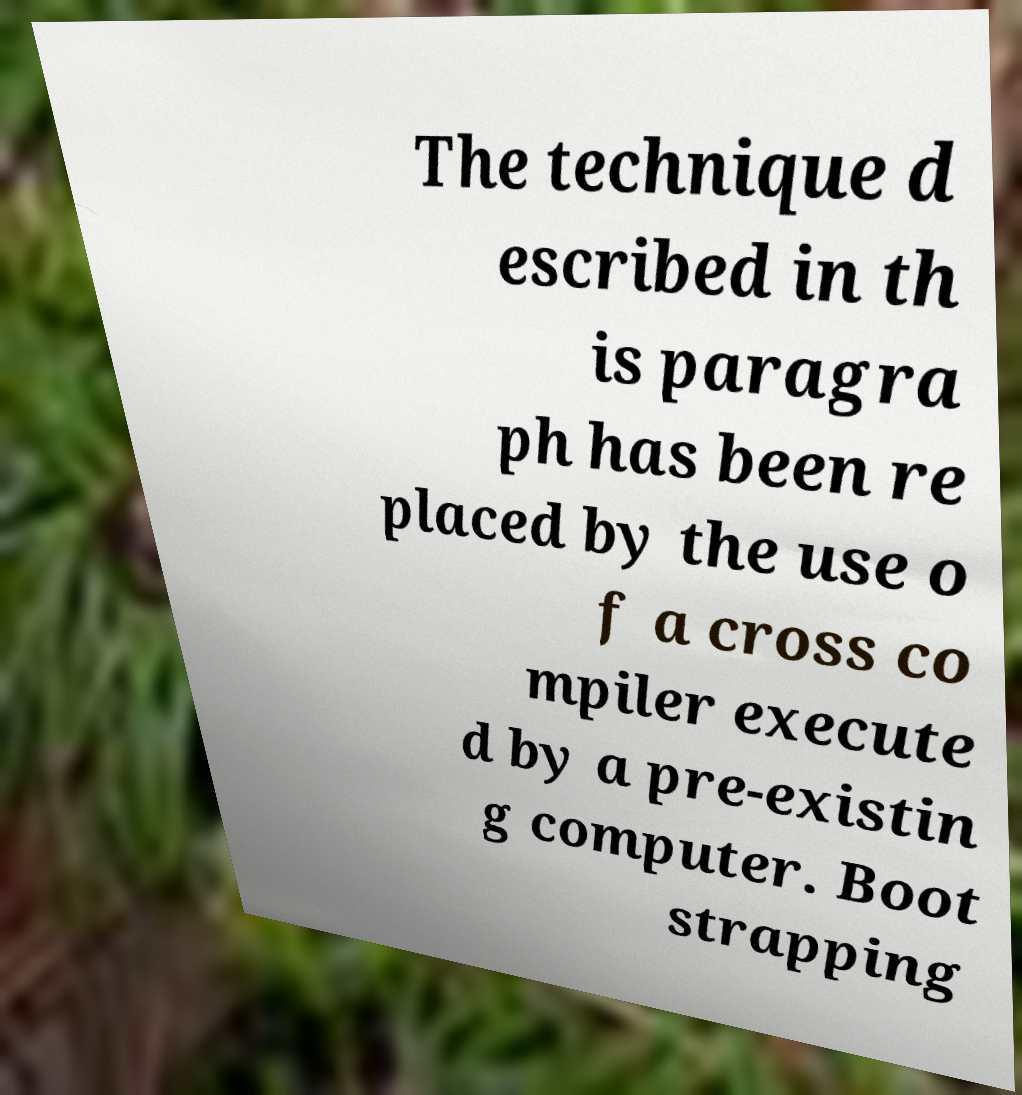Can you read and provide the text displayed in the image?This photo seems to have some interesting text. Can you extract and type it out for me? The technique d escribed in th is paragra ph has been re placed by the use o f a cross co mpiler execute d by a pre-existin g computer. Boot strapping 